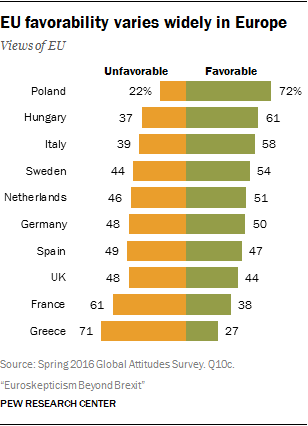Highlight a few significant elements in this photo. There are only two colors in the bar. The median value of the Favorable bar is 50.5. 